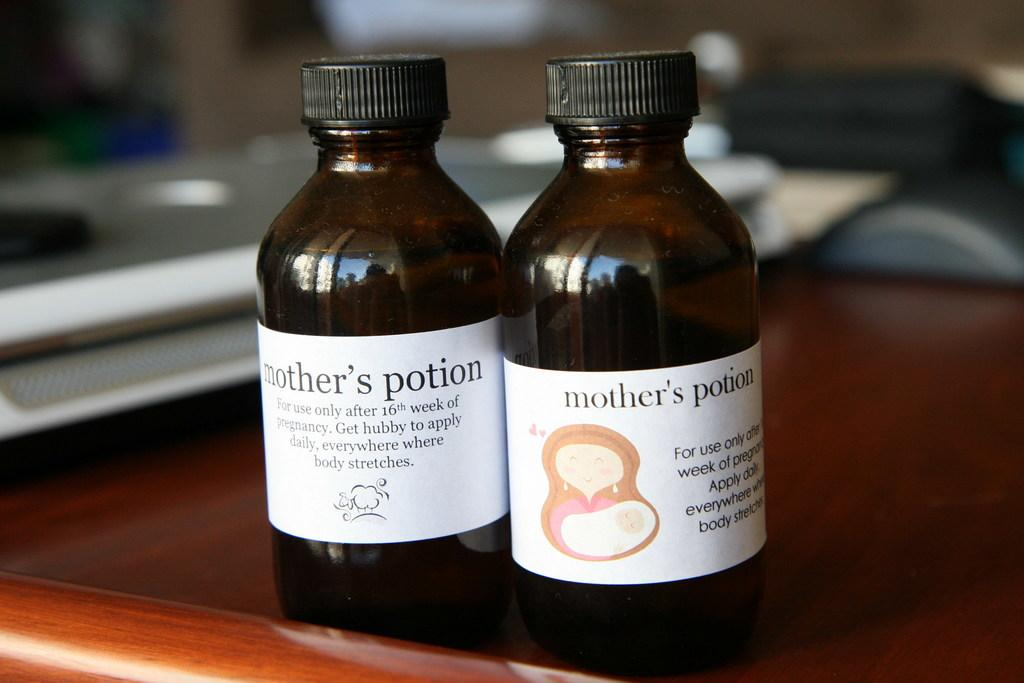<image>
Write a terse but informative summary of the picture. the word potion that is on the dark bottles 